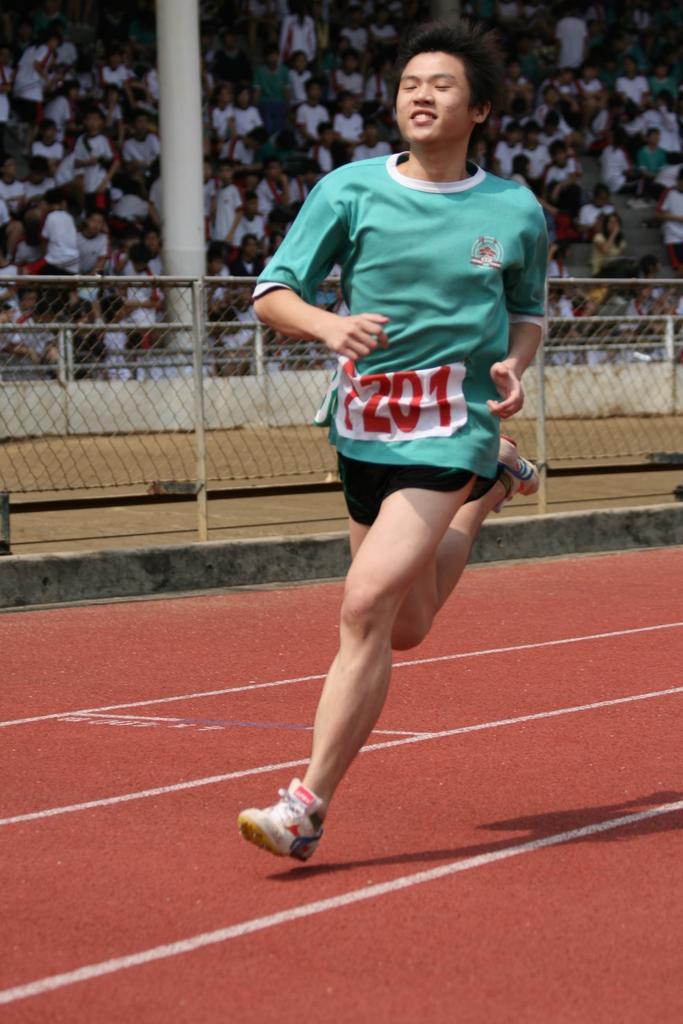Could you give a brief overview of what you see in this image? In this image we can see a person green color T-shirt running and in the background of the image there is fencing, there are some persons standing and sitting. 